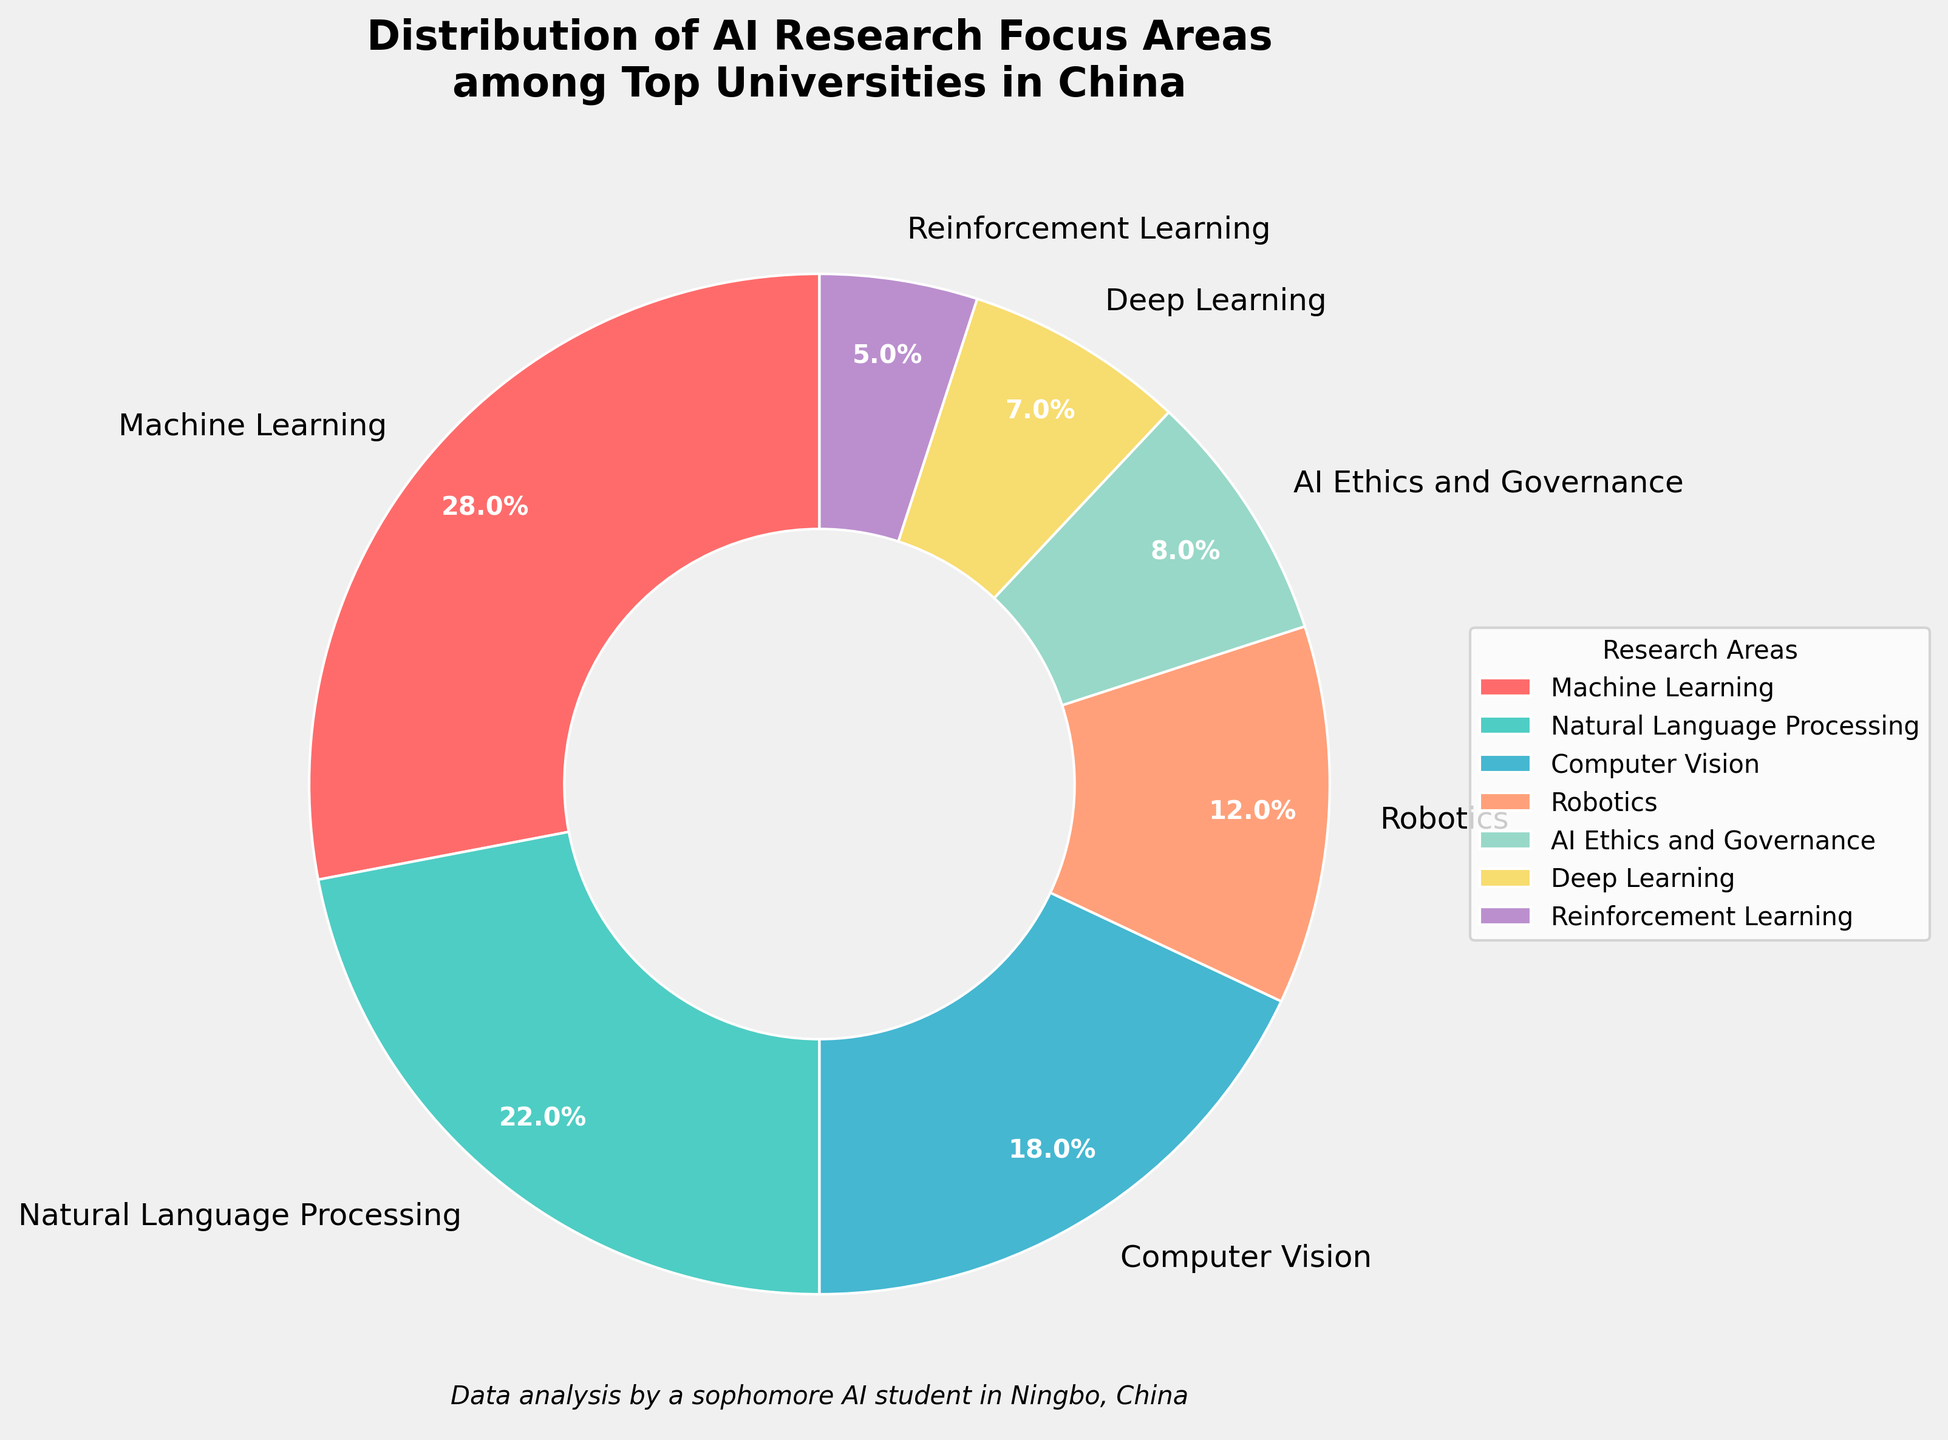Which AI research focus area holds the largest share? The pie chart shows the distribution of AI research focus areas. The largest wedge corresponds to Machine Learning with 28%.
Answer: Machine Learning What is the combined percentage of research focused on Computer Vision and Robotics? The percentages for Computer Vision and Robotics are 18% and 12%, respectively. Adding these together, 18% + 12% = 30%.
Answer: 30% How does the percentage dedicated to Natural Language Processing compare to that for AI Ethics and Governance? Natural Language Processing has 22% while AI Ethics and Governance has 8%. Comparing these, 22% is greater than 8%.
Answer: Greater Which research focus areas combined make up over 50% of the distribution? Machine Learning (28%) and Natural Language Processing (22%) combined make up 50%. Including Computer Vision (18%) would exceed 50%, resulting in a cumulative 68%.
Answer: Machine Learning, Natural Language Processing, Computer Vision By how much does the focus on Machine Learning exceed Reinforcement Learning? Machine Learning is at 28% and Reinforcement Learning at 5%. The difference between them is 28% - 5% = 23%.
Answer: 23% List the focus areas in order of descending percentage share. The research areas ranked in descending order are Machine Learning (28%), Natural Language Processing (22%), Computer Vision (18%), Robotics (12%), AI Ethics and Governance (8%), Deep Learning (7%), and Reinforcement Learning (5%).
Answer: Machine Learning, Natural Language Processing, Computer Vision, Robotics, AI Ethics and Governance, Deep Learning, Reinforcement Learning Which focus area has the smallest share and what is its percentage? The pie chart shows that Reinforcement Learning has the smallest share at 5%.
Answer: Reinforcement Learning, 5% Is there any focus area with a percentage share that is exactly double another? Robotics at 12% is exactly double that of AI Ethics and Governance at 6%. Verifying, there is an error; Correctly, no areas have exactly double the share of another.
Answer: No What is the median percentage among the listed focus areas? Arranging the percentages in ascending order: 5%, 7%, 8%, 12%, 18%, 22%, 28%. The median is the middle value, which is 12%.
Answer: 12% If we group the focus areas into a "Top 3" category (based on largest shares), what percentage does this group hold? The top three areas (Machine Learning, Natural Language Processing, Computer Vision) have percentages of 28%, 22%, and 18%. Adding them: 28% + 22% + 18% = 68%.
Answer: 68% 